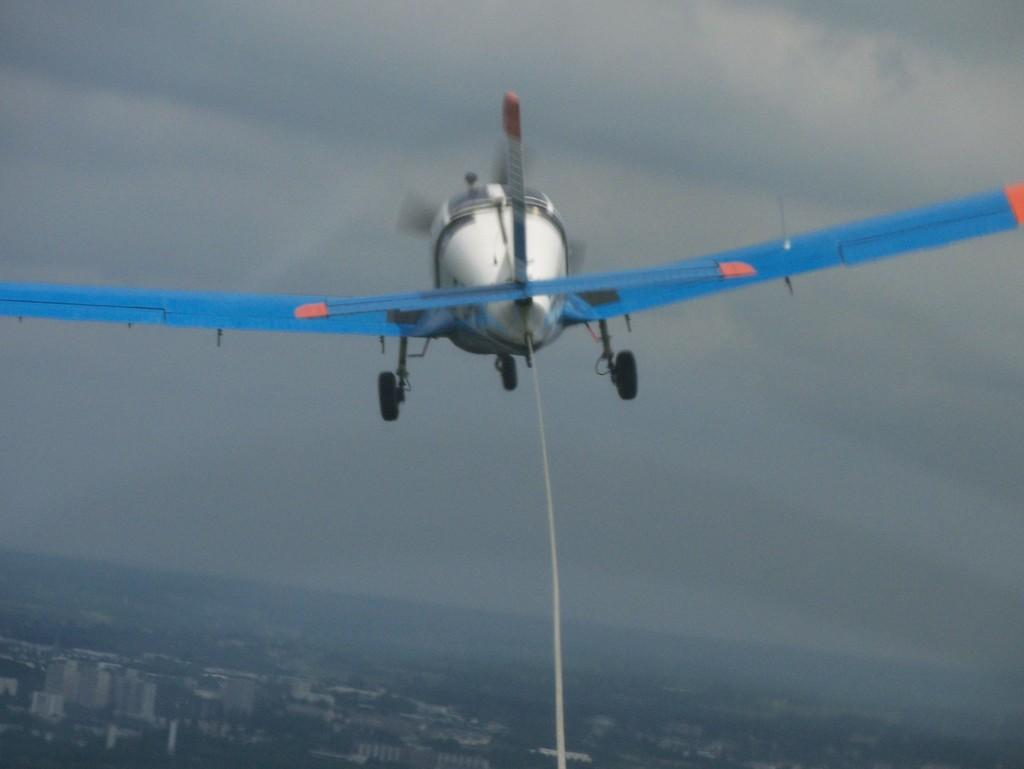What is the main subject of the image? The main subject of the image is a helicopter. Can you describe the position of the helicopter in the image? The helicopter is in the air in the image. What can be seen at the bottom of the image? There are buildings at the bottom of the image. What is visible at the top of the image? The sky is visible at the top of the image. What type of sock is hanging from the helicopter in the image? There is no sock present in the image; it features a helicopter in the air with buildings and sky visible. How many eggs are visible in the image? There are no eggs present in the image. 